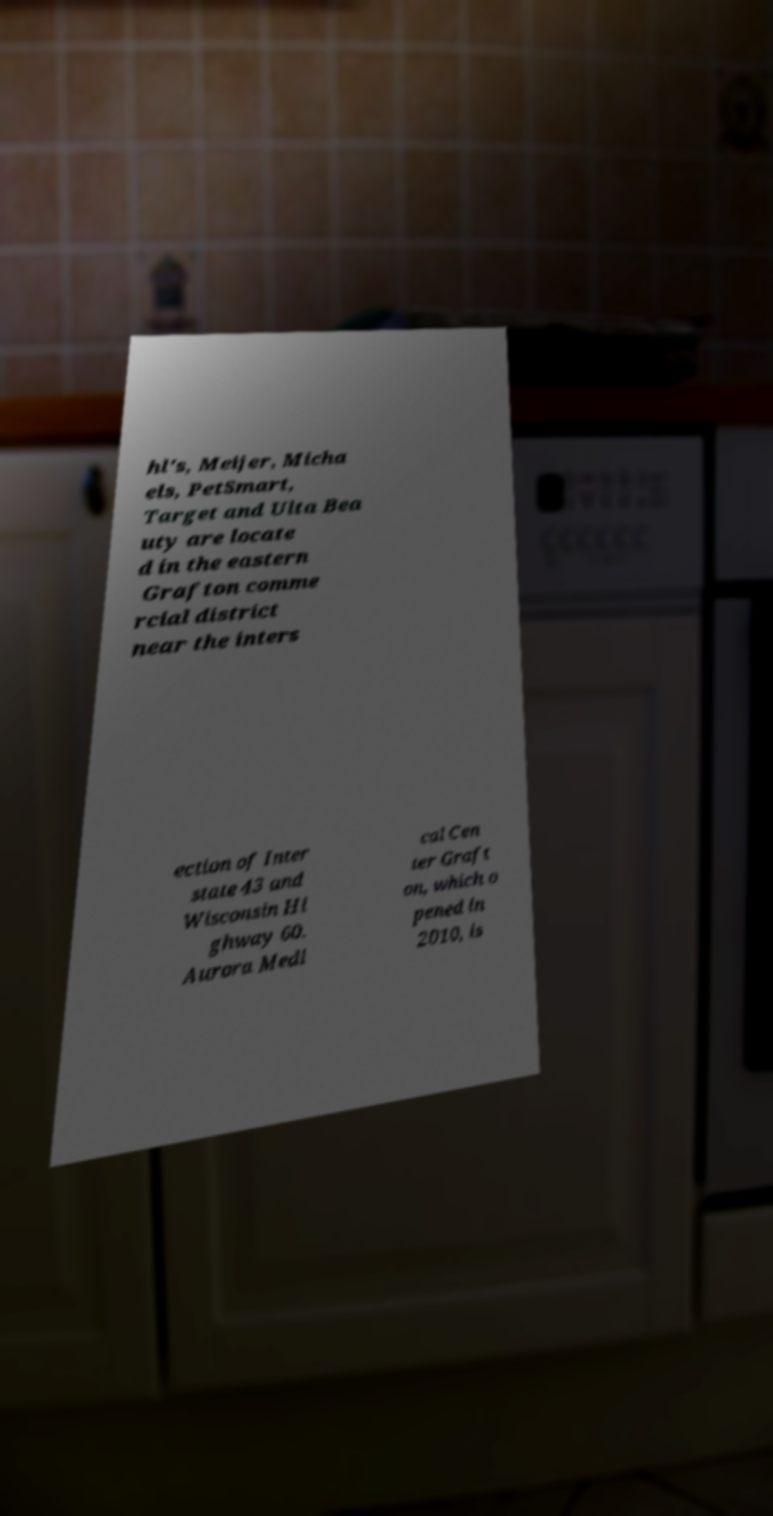Please identify and transcribe the text found in this image. hl's, Meijer, Micha els, PetSmart, Target and Ulta Bea uty are locate d in the eastern Grafton comme rcial district near the inters ection of Inter state 43 and Wisconsin Hi ghway 60. Aurora Medi cal Cen ter Graft on, which o pened in 2010, is 